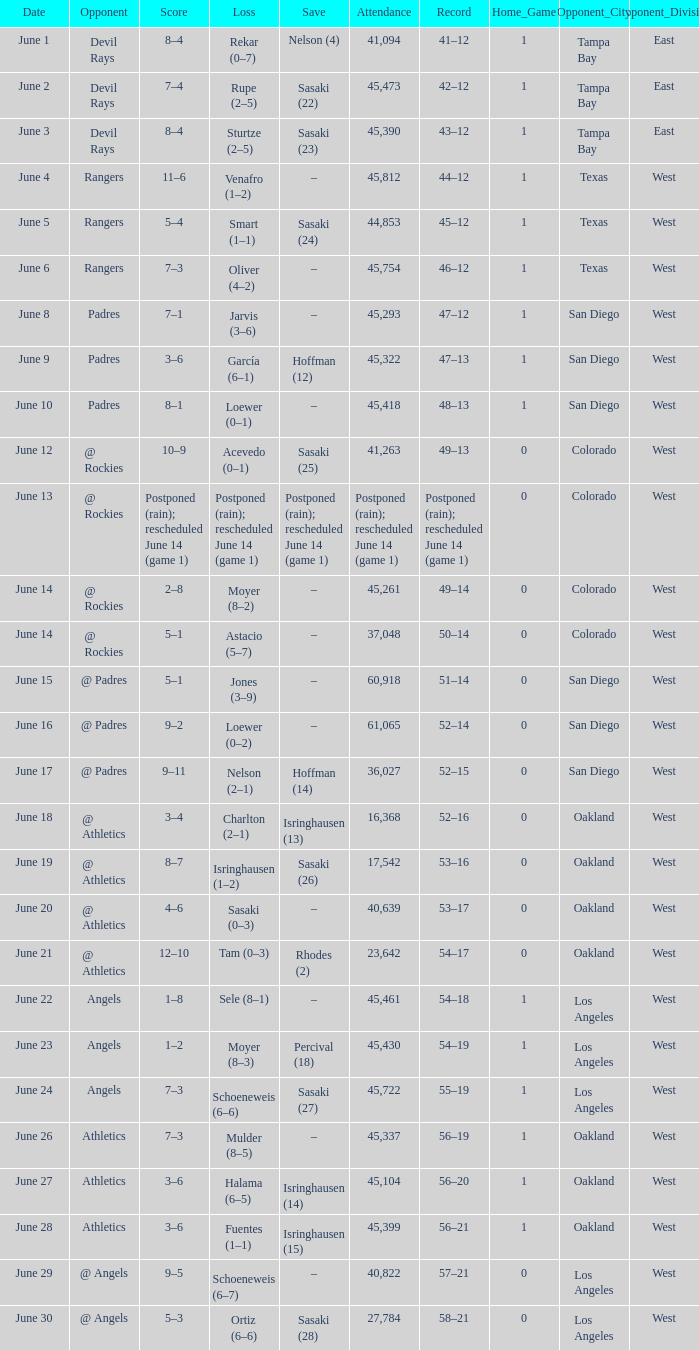What was the tally of the mariners match when they had a record of 56–21? 3–6. 